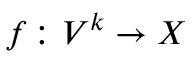Convert formula to latex. <formula><loc_0><loc_0><loc_500><loc_500>f \colon V ^ { k } \to X</formula> 